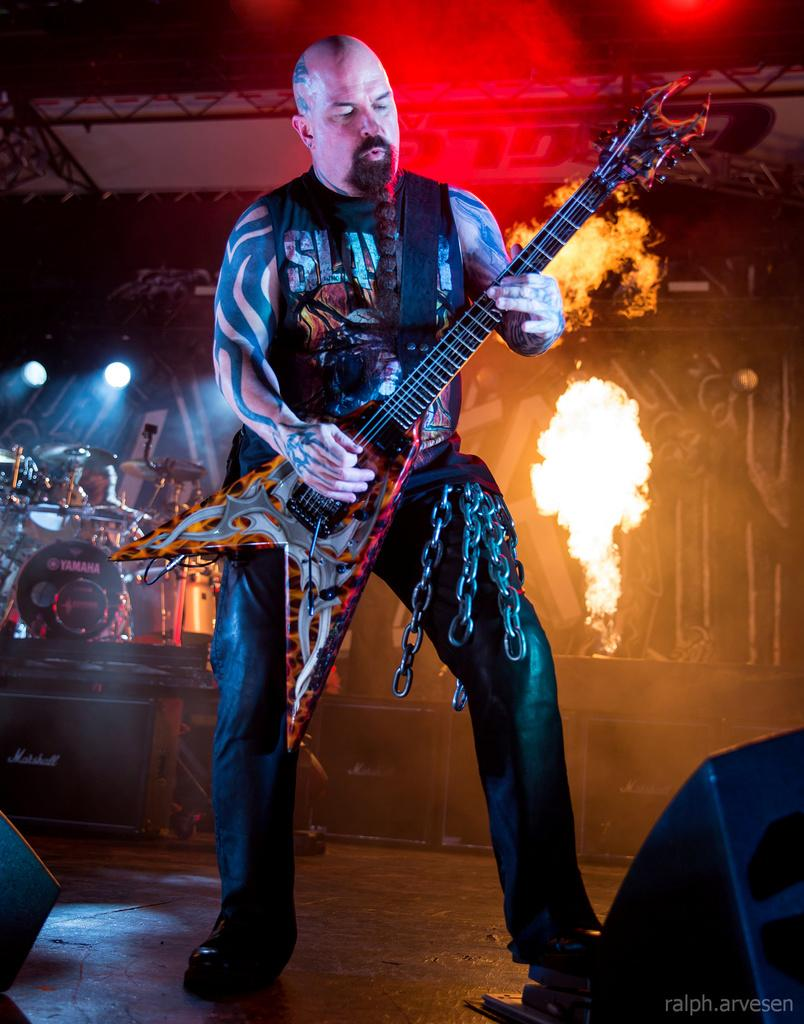What is the man in the image doing? The man is playing a guitar in the image. Are there any other musical instruments visible in the image? Yes, there is a musical instrument on the left side of the image, which appears to be a speaker. What is attached to the man's leg in the image? The man has chains attached to his leg in the image. What type of house is visible in the image? There is no house present in the image. How many cents are visible on the guitar in the image? There are no cents visible on the guitar or any other object in the image. 